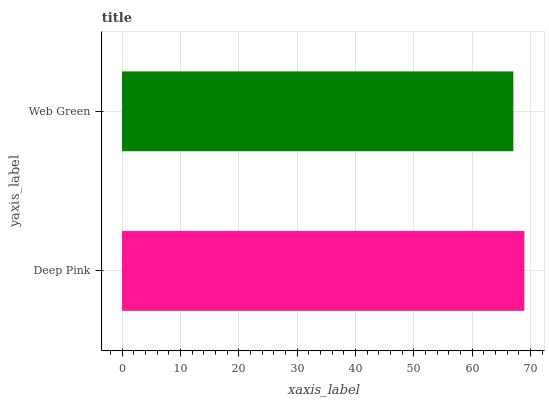Is Web Green the minimum?
Answer yes or no. Yes. Is Deep Pink the maximum?
Answer yes or no. Yes. Is Web Green the maximum?
Answer yes or no. No. Is Deep Pink greater than Web Green?
Answer yes or no. Yes. Is Web Green less than Deep Pink?
Answer yes or no. Yes. Is Web Green greater than Deep Pink?
Answer yes or no. No. Is Deep Pink less than Web Green?
Answer yes or no. No. Is Deep Pink the high median?
Answer yes or no. Yes. Is Web Green the low median?
Answer yes or no. Yes. Is Web Green the high median?
Answer yes or no. No. Is Deep Pink the low median?
Answer yes or no. No. 